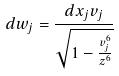Convert formula to latex. <formula><loc_0><loc_0><loc_500><loc_500>d w _ { j } = \frac { d x _ { j } v _ { j } } { \sqrt { 1 - \frac { v _ { j } ^ { 6 } } { z ^ { 6 } } } }</formula> 